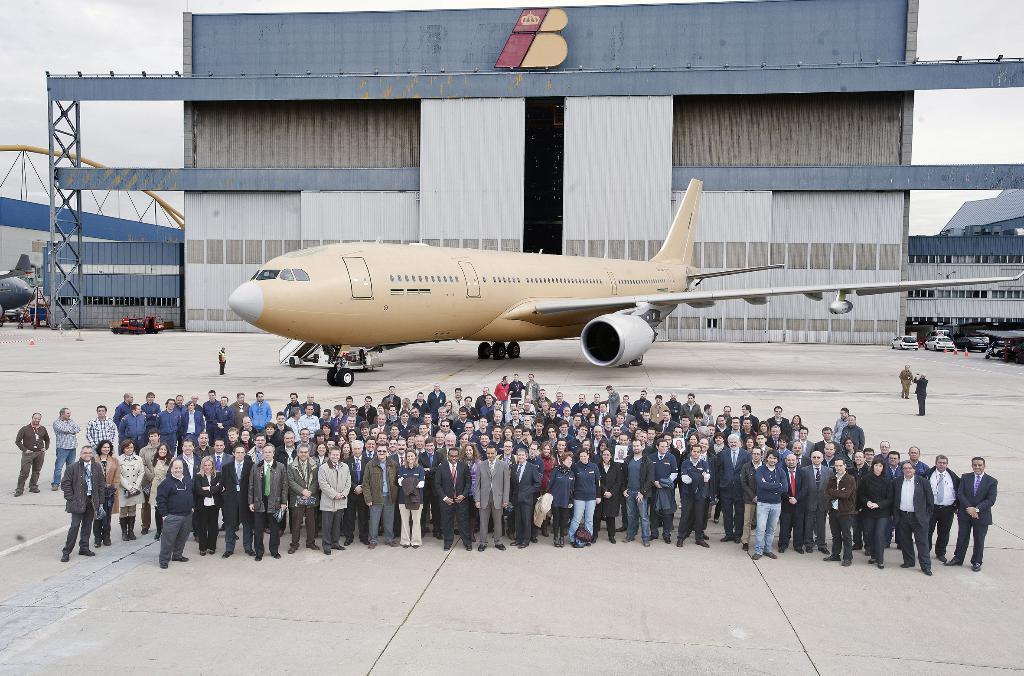What is the main subject of the image? The main subject of the image is airplanes. What other types of transportation can be seen in the image? There are vehicles in the image. What is the location of the people in the image? There are people on the ground in the image. What can be seen in the background of the image? There are buildings and the sky visible in the background of the image. How many beds are visible in the image? There are no beds present in the image. Can you describe the frog's behavior in the image? There is no frog present in the image. 